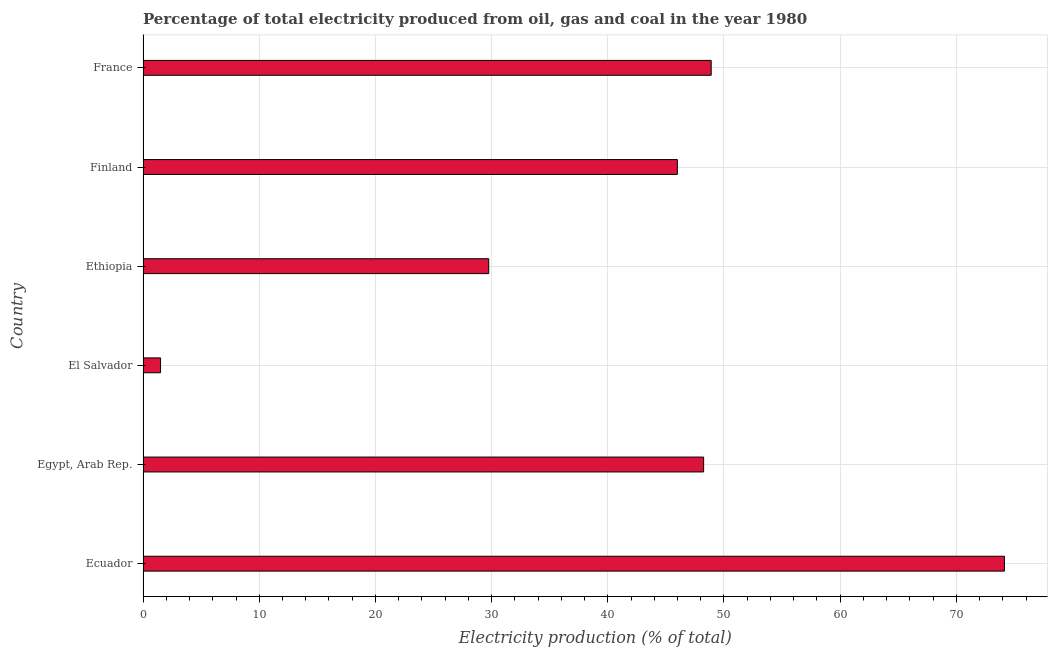Does the graph contain any zero values?
Make the answer very short. No. Does the graph contain grids?
Provide a short and direct response. Yes. What is the title of the graph?
Provide a short and direct response. Percentage of total electricity produced from oil, gas and coal in the year 1980. What is the label or title of the X-axis?
Keep it short and to the point. Electricity production (% of total). What is the electricity production in El Salvador?
Keep it short and to the point. 1.51. Across all countries, what is the maximum electricity production?
Keep it short and to the point. 74.14. Across all countries, what is the minimum electricity production?
Provide a succinct answer. 1.51. In which country was the electricity production maximum?
Your answer should be very brief. Ecuador. In which country was the electricity production minimum?
Offer a very short reply. El Salvador. What is the sum of the electricity production?
Your answer should be compact. 248.54. What is the difference between the electricity production in Ecuador and Ethiopia?
Ensure brevity in your answer.  44.39. What is the average electricity production per country?
Provide a succinct answer. 41.42. What is the median electricity production?
Your response must be concise. 47.12. What is the ratio of the electricity production in Egypt, Arab Rep. to that in Finland?
Your response must be concise. 1.05. Is the electricity production in Ecuador less than that in Egypt, Arab Rep.?
Make the answer very short. No. Is the difference between the electricity production in Ecuador and Ethiopia greater than the difference between any two countries?
Your answer should be very brief. No. What is the difference between the highest and the second highest electricity production?
Give a very brief answer. 25.24. What is the difference between the highest and the lowest electricity production?
Your answer should be very brief. 72.63. In how many countries, is the electricity production greater than the average electricity production taken over all countries?
Make the answer very short. 4. Are the values on the major ticks of X-axis written in scientific E-notation?
Your response must be concise. No. What is the Electricity production (% of total) of Ecuador?
Your response must be concise. 74.14. What is the Electricity production (% of total) of Egypt, Arab Rep.?
Your answer should be compact. 48.25. What is the Electricity production (% of total) of El Salvador?
Give a very brief answer. 1.51. What is the Electricity production (% of total) in Ethiopia?
Offer a terse response. 29.75. What is the Electricity production (% of total) of Finland?
Offer a terse response. 45.99. What is the Electricity production (% of total) of France?
Your answer should be compact. 48.9. What is the difference between the Electricity production (% of total) in Ecuador and Egypt, Arab Rep.?
Make the answer very short. 25.89. What is the difference between the Electricity production (% of total) in Ecuador and El Salvador?
Ensure brevity in your answer.  72.63. What is the difference between the Electricity production (% of total) in Ecuador and Ethiopia?
Offer a very short reply. 44.39. What is the difference between the Electricity production (% of total) in Ecuador and Finland?
Keep it short and to the point. 28.15. What is the difference between the Electricity production (% of total) in Ecuador and France?
Provide a short and direct response. 25.24. What is the difference between the Electricity production (% of total) in Egypt, Arab Rep. and El Salvador?
Offer a terse response. 46.74. What is the difference between the Electricity production (% of total) in Egypt, Arab Rep. and Ethiopia?
Offer a very short reply. 18.5. What is the difference between the Electricity production (% of total) in Egypt, Arab Rep. and Finland?
Your response must be concise. 2.26. What is the difference between the Electricity production (% of total) in Egypt, Arab Rep. and France?
Give a very brief answer. -0.65. What is the difference between the Electricity production (% of total) in El Salvador and Ethiopia?
Provide a succinct answer. -28.25. What is the difference between the Electricity production (% of total) in El Salvador and Finland?
Make the answer very short. -44.48. What is the difference between the Electricity production (% of total) in El Salvador and France?
Provide a succinct answer. -47.39. What is the difference between the Electricity production (% of total) in Ethiopia and Finland?
Give a very brief answer. -16.24. What is the difference between the Electricity production (% of total) in Ethiopia and France?
Ensure brevity in your answer.  -19.15. What is the difference between the Electricity production (% of total) in Finland and France?
Offer a very short reply. -2.91. What is the ratio of the Electricity production (% of total) in Ecuador to that in Egypt, Arab Rep.?
Ensure brevity in your answer.  1.54. What is the ratio of the Electricity production (% of total) in Ecuador to that in El Salvador?
Provide a short and direct response. 49.2. What is the ratio of the Electricity production (% of total) in Ecuador to that in Ethiopia?
Your answer should be very brief. 2.49. What is the ratio of the Electricity production (% of total) in Ecuador to that in Finland?
Offer a terse response. 1.61. What is the ratio of the Electricity production (% of total) in Ecuador to that in France?
Your response must be concise. 1.52. What is the ratio of the Electricity production (% of total) in Egypt, Arab Rep. to that in El Salvador?
Offer a very short reply. 32.02. What is the ratio of the Electricity production (% of total) in Egypt, Arab Rep. to that in Ethiopia?
Give a very brief answer. 1.62. What is the ratio of the Electricity production (% of total) in Egypt, Arab Rep. to that in Finland?
Your response must be concise. 1.05. What is the ratio of the Electricity production (% of total) in El Salvador to that in Ethiopia?
Provide a short and direct response. 0.05. What is the ratio of the Electricity production (% of total) in El Salvador to that in Finland?
Ensure brevity in your answer.  0.03. What is the ratio of the Electricity production (% of total) in El Salvador to that in France?
Ensure brevity in your answer.  0.03. What is the ratio of the Electricity production (% of total) in Ethiopia to that in Finland?
Make the answer very short. 0.65. What is the ratio of the Electricity production (% of total) in Ethiopia to that in France?
Your answer should be very brief. 0.61. What is the ratio of the Electricity production (% of total) in Finland to that in France?
Ensure brevity in your answer.  0.94. 